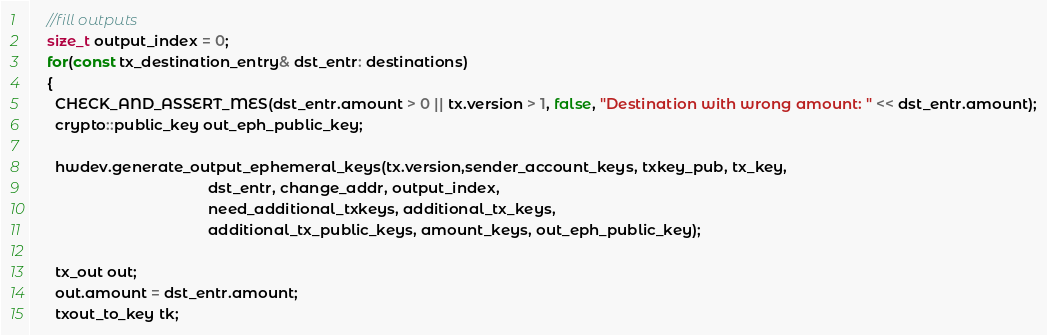<code> <loc_0><loc_0><loc_500><loc_500><_C++_>    //fill outputs
    size_t output_index = 0;
    for(const tx_destination_entry& dst_entr: destinations)
    {
      CHECK_AND_ASSERT_MES(dst_entr.amount > 0 || tx.version > 1, false, "Destination with wrong amount: " << dst_entr.amount);
      crypto::public_key out_eph_public_key;

      hwdev.generate_output_ephemeral_keys(tx.version,sender_account_keys, txkey_pub, tx_key,
                                           dst_entr, change_addr, output_index,
                                           need_additional_txkeys, additional_tx_keys,
                                           additional_tx_public_keys, amount_keys, out_eph_public_key);

      tx_out out;
      out.amount = dst_entr.amount;
      txout_to_key tk;</code> 